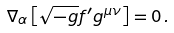Convert formula to latex. <formula><loc_0><loc_0><loc_500><loc_500>\nabla _ { \alpha } \left [ \sqrt { - g } f ^ { \prime } g ^ { \mu \nu } \right ] = 0 \, .</formula> 